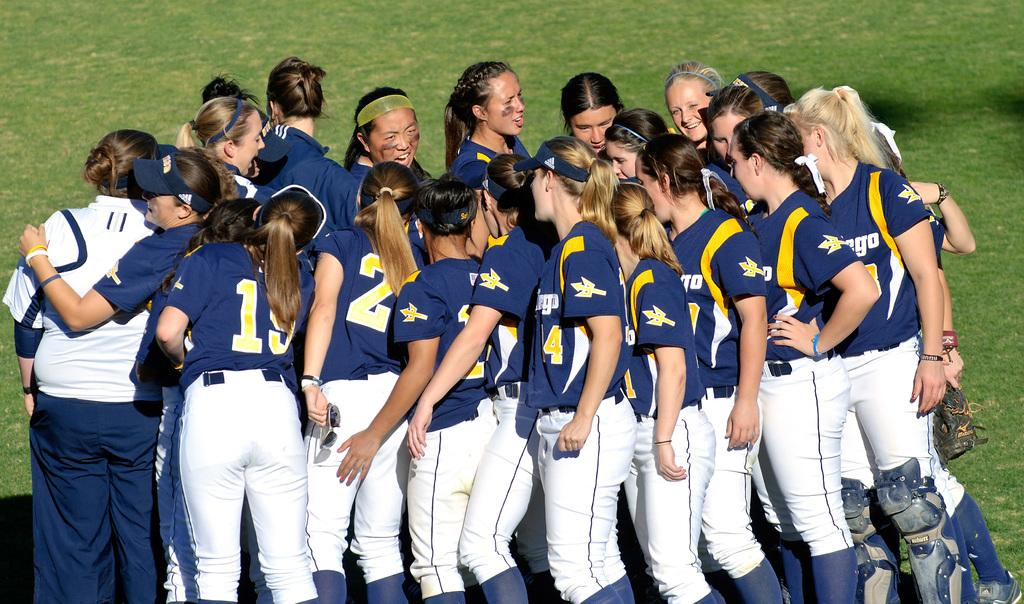<image>
Render a clear and concise summary of the photo. group of women ball players, numbers 19 & 4 are numbers showing 